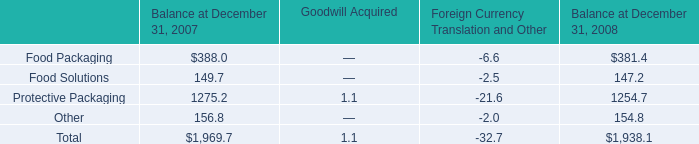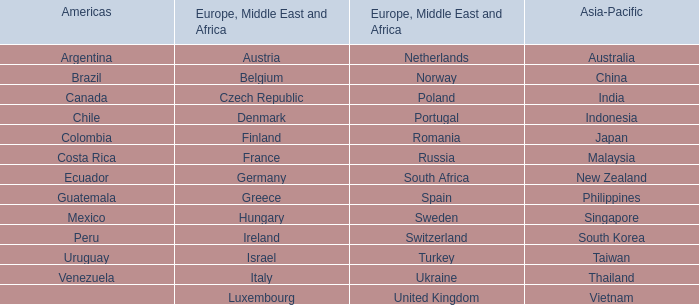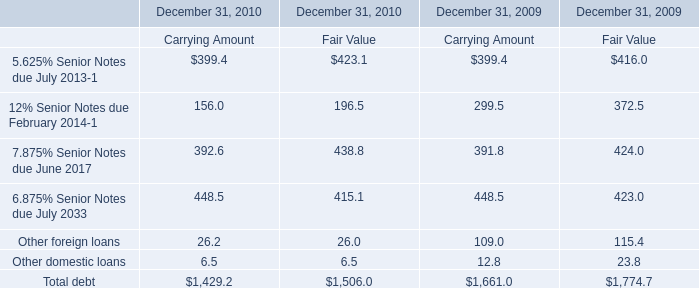The total amount of which section ranks first for December 31, 2009? 
Computations: (((((416.0 + 372.5) + 424.0) + 423.0) + 115.4) + 23.8)
Answer: 1774.7. 